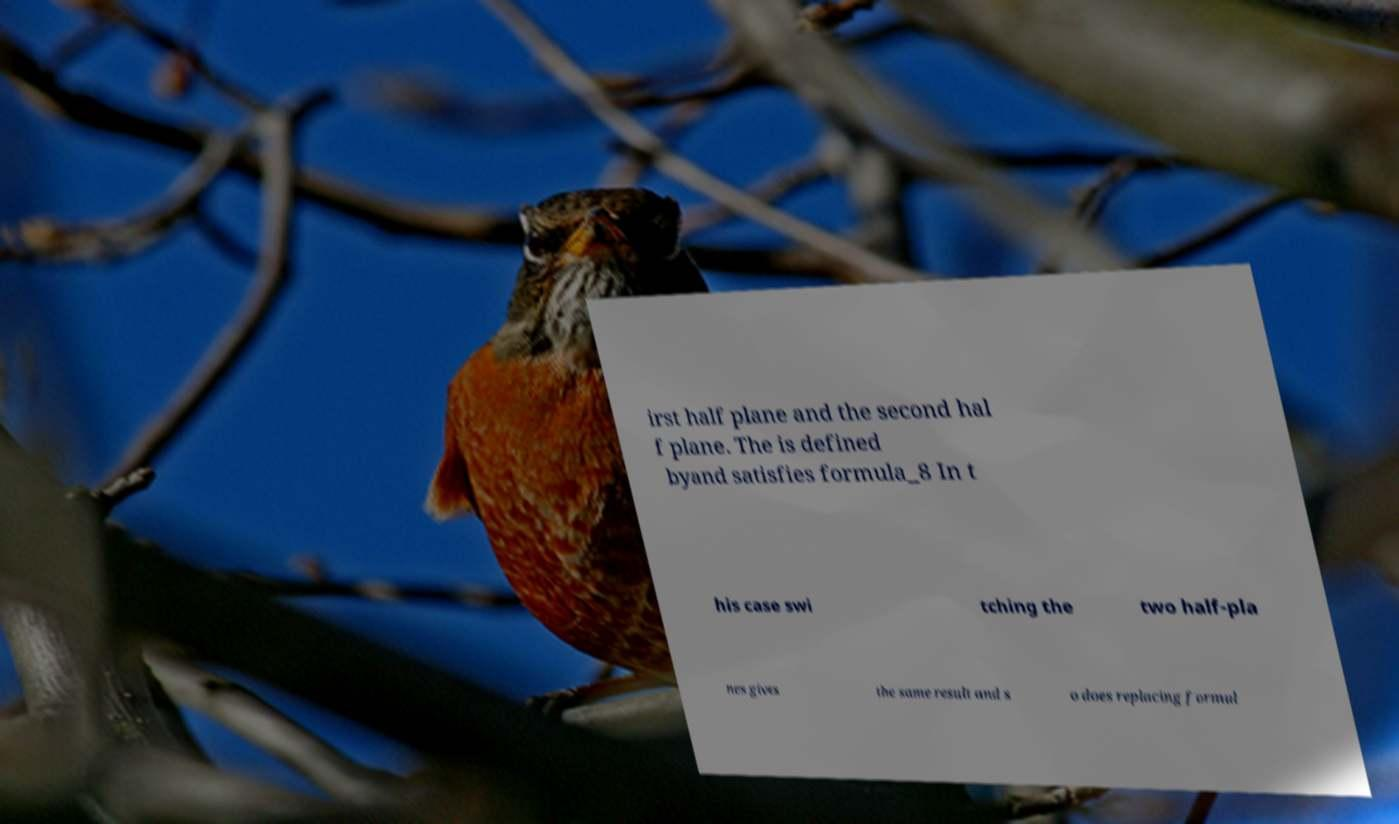There's text embedded in this image that I need extracted. Can you transcribe it verbatim? irst half plane and the second hal f plane. The is defined byand satisfies formula_8 In t his case swi tching the two half-pla nes gives the same result and s o does replacing formul 